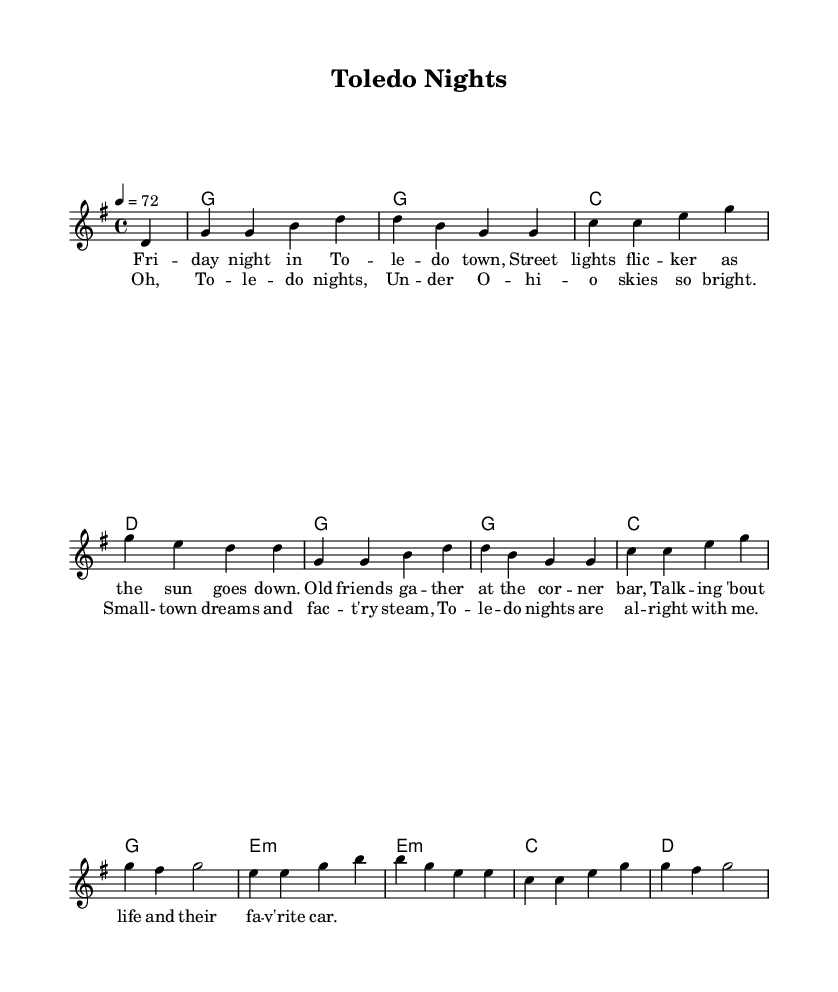What is the key signature of this music? The key signature is G major, which has one sharp (F#). This can be identified by looking at the key signature indicated at the beginning of the score.
Answer: G major What is the time signature of this music? The time signature is 4/4, shown at the beginning of the staff. This means there are four beats in a measure, and the quarter note gets one beat.
Answer: 4/4 What is the tempo marking for this piece? The tempo marking is 72 beats per minute, specified at the start of the score. It indicates the speed at which the piece should be played.
Answer: 72 How many measures are in the melody? The melody consists of eight measures. Counting the distinct sections separated by bar lines will provide the total count.
Answer: 8 What type of chords are used in the harmonies? The chords consist of major and minor chords, specifically: G, C, D, and E minor. This can be determined by analyzing the chords written in the chord mode section of the score.
Answer: Major and minor chords What is the mood conveyed in the lyrics of the chorus? The mood is reflective and nostalgic, as it speaks of small-town dreams and the comfort of Toledo nights. This can be inferred from the content and phrasing in the lyrics, which emphasize positive memories related to rural life.
Answer: Reflective and nostalgic What theme is explored in the lyrics of the song? The theme is small-town life and community connections in Toledo, Ohio. This is evident from the lyrics that highlight gatherings, conversations, and local scenery.
Answer: Small-town life 